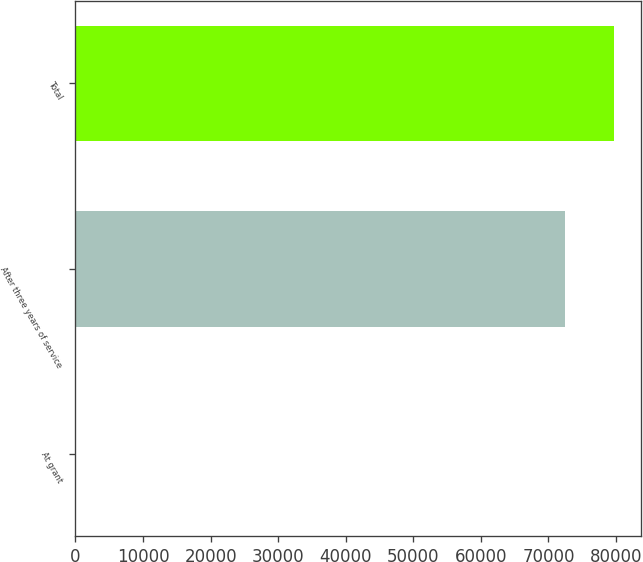Convert chart. <chart><loc_0><loc_0><loc_500><loc_500><bar_chart><fcel>At grant<fcel>After three years of service<fcel>Total<nl><fcel>3.05<fcel>72470<fcel>79716.7<nl></chart> 